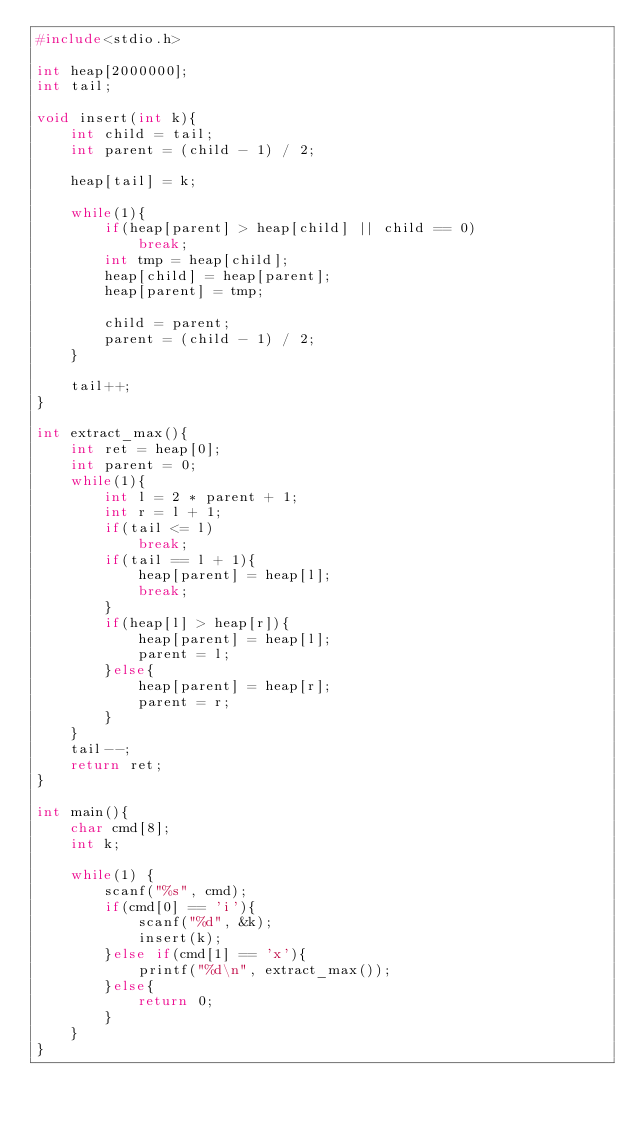Convert code to text. <code><loc_0><loc_0><loc_500><loc_500><_C_>#include<stdio.h>

int heap[2000000];
int tail;

void insert(int k){
    int child = tail;
    int parent = (child - 1) / 2;

    heap[tail] = k;

    while(1){
        if(heap[parent] > heap[child] || child == 0)
            break;
        int tmp = heap[child];
        heap[child] = heap[parent];
        heap[parent] = tmp;

        child = parent;
        parent = (child - 1) / 2;
    }

    tail++;
}

int extract_max(){
    int ret = heap[0];
    int parent = 0;
    while(1){
        int l = 2 * parent + 1;
        int r = l + 1;
        if(tail <= l)
            break;
        if(tail == l + 1){
            heap[parent] = heap[l];
            break;
        }
        if(heap[l] > heap[r]){
            heap[parent] = heap[l];
            parent = l;
        }else{
            heap[parent] = heap[r];
            parent = r;
        }
    }
    tail--;
    return ret;
}

int main(){
    char cmd[8];
    int k;

    while(1) {
        scanf("%s", cmd);
        if(cmd[0] == 'i'){
            scanf("%d", &k);
            insert(k);
        }else if(cmd[1] == 'x'){
            printf("%d\n", extract_max());
        }else{
            return 0;
        }
    }
}</code> 